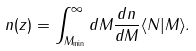Convert formula to latex. <formula><loc_0><loc_0><loc_500><loc_500>n ( z ) = \int _ { M _ { \min } } ^ { \infty } d M \frac { d n } { d M } \langle N | M \rangle .</formula> 